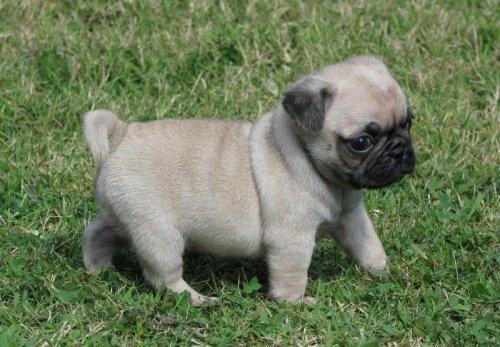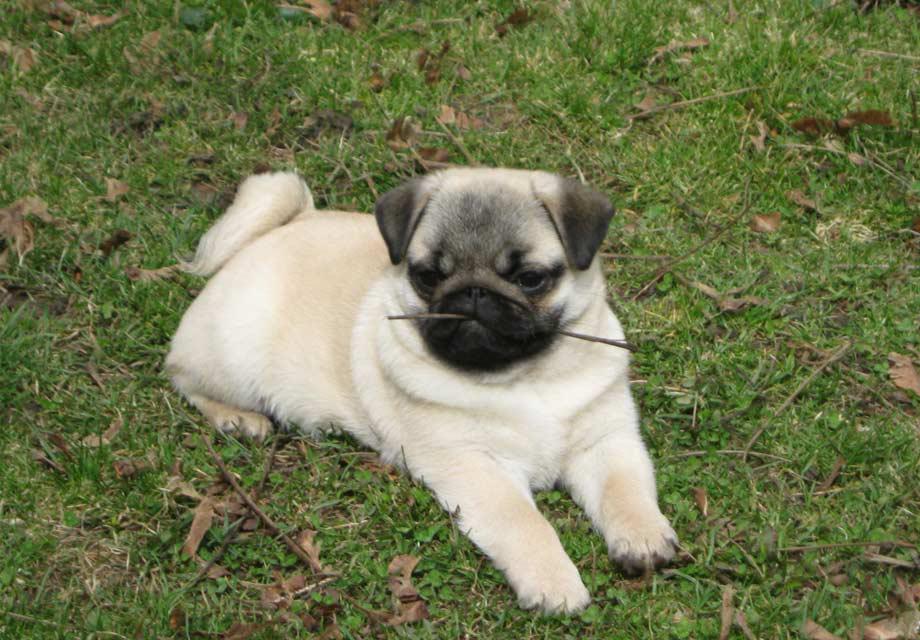The first image is the image on the left, the second image is the image on the right. For the images shown, is this caption "Each image shows one pug posed outdoors, and one image shows a standing pug while the other shows a reclining pug." true? Answer yes or no. Yes. 